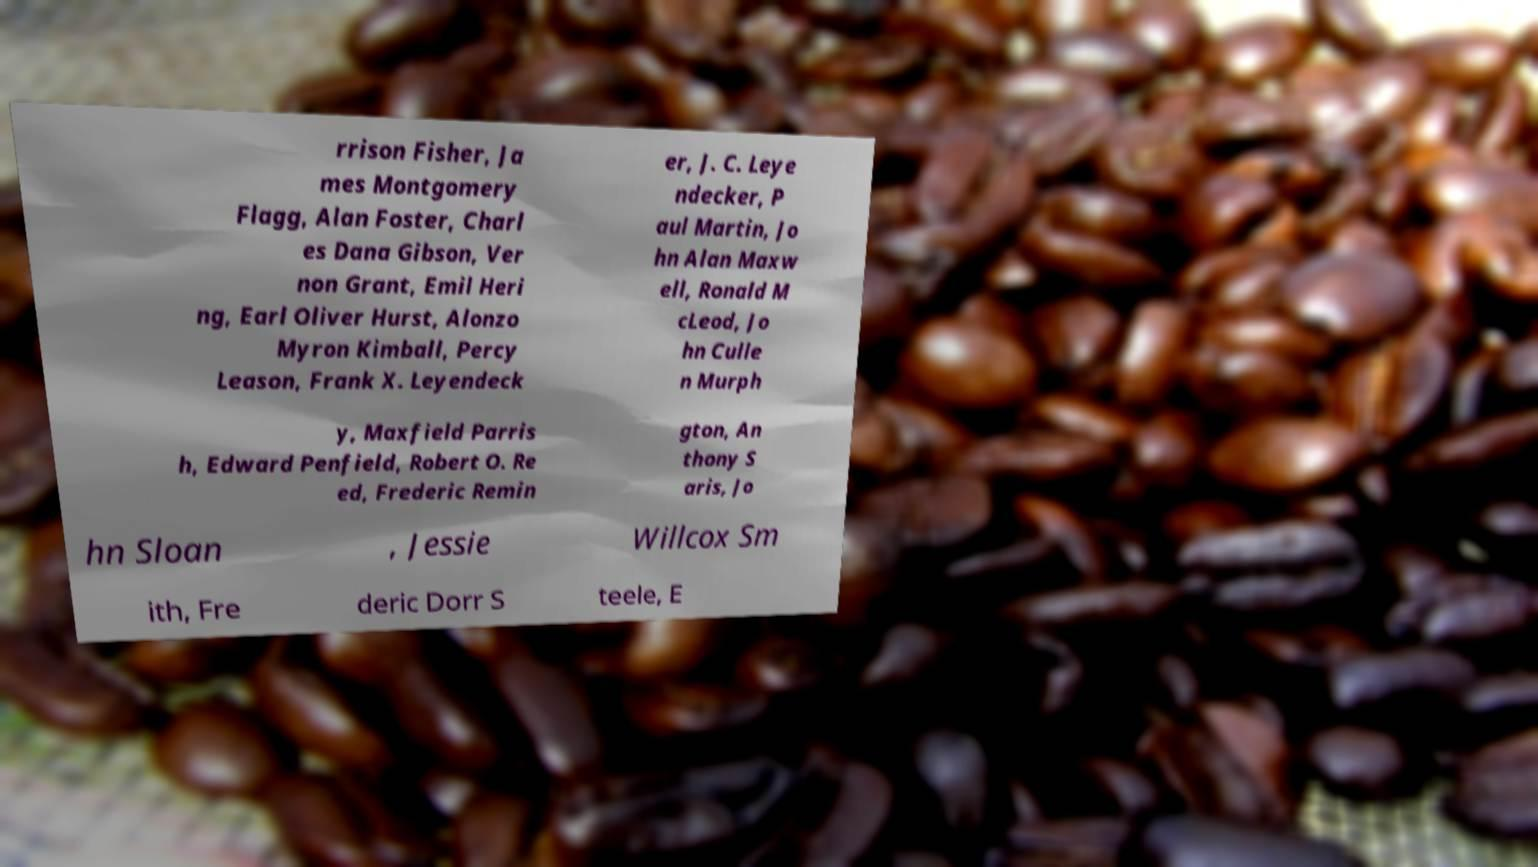Could you assist in decoding the text presented in this image and type it out clearly? rrison Fisher, Ja mes Montgomery Flagg, Alan Foster, Charl es Dana Gibson, Ver non Grant, Emil Heri ng, Earl Oliver Hurst, Alonzo Myron Kimball, Percy Leason, Frank X. Leyendeck er, J. C. Leye ndecker, P aul Martin, Jo hn Alan Maxw ell, Ronald M cLeod, Jo hn Culle n Murph y, Maxfield Parris h, Edward Penfield, Robert O. Re ed, Frederic Remin gton, An thony S aris, Jo hn Sloan , Jessie Willcox Sm ith, Fre deric Dorr S teele, E 